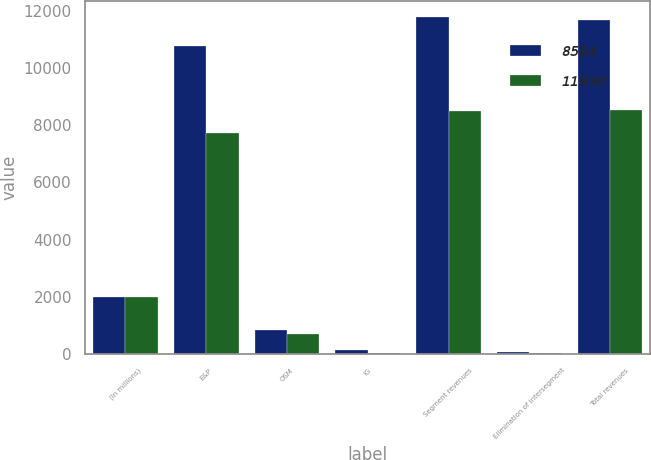Convert chart to OTSL. <chart><loc_0><loc_0><loc_500><loc_500><stacked_bar_chart><ecel><fcel>(In millions)<fcel>E&P<fcel>OSM<fcel>IG<fcel>Segment revenues<fcel>Elimination of intersegment<fcel>Total revenues<nl><fcel>8524<fcel>2010<fcel>10782<fcel>833<fcel>150<fcel>11765<fcel>75<fcel>11690<nl><fcel>11690<fcel>2009<fcel>7738<fcel>692<fcel>50<fcel>8480<fcel>28<fcel>8524<nl></chart> 